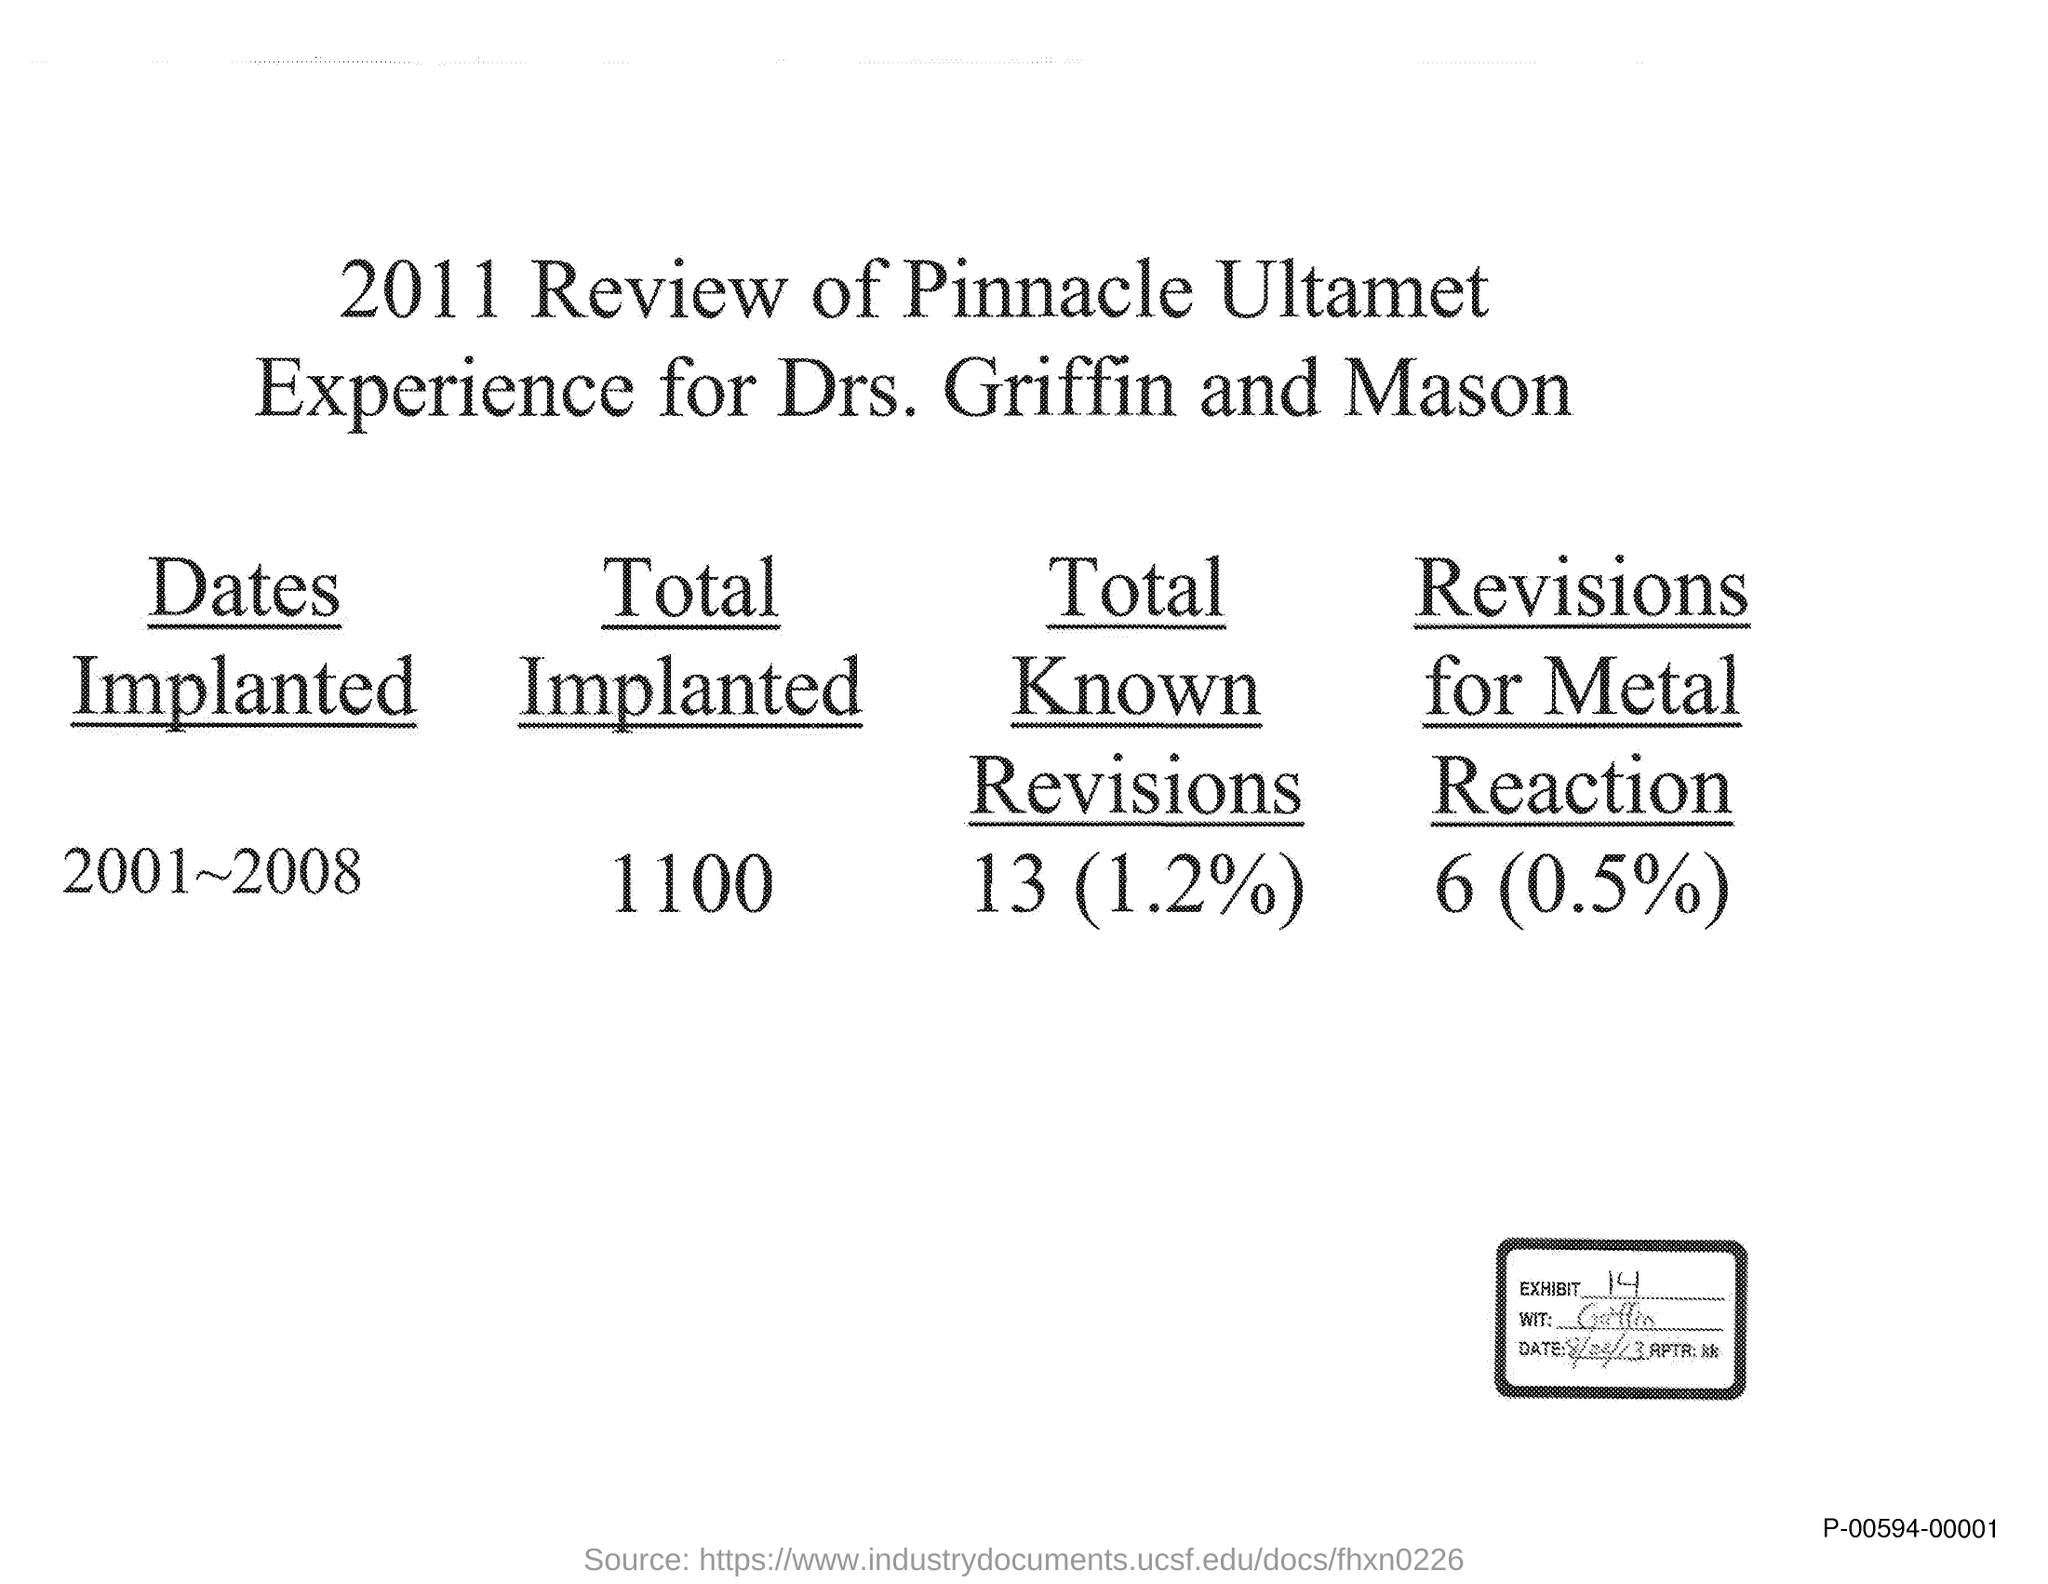Draw attention to some important aspects in this diagram. As of today, a total of 1,100 implants have been made. The Exhibit number is 14. 